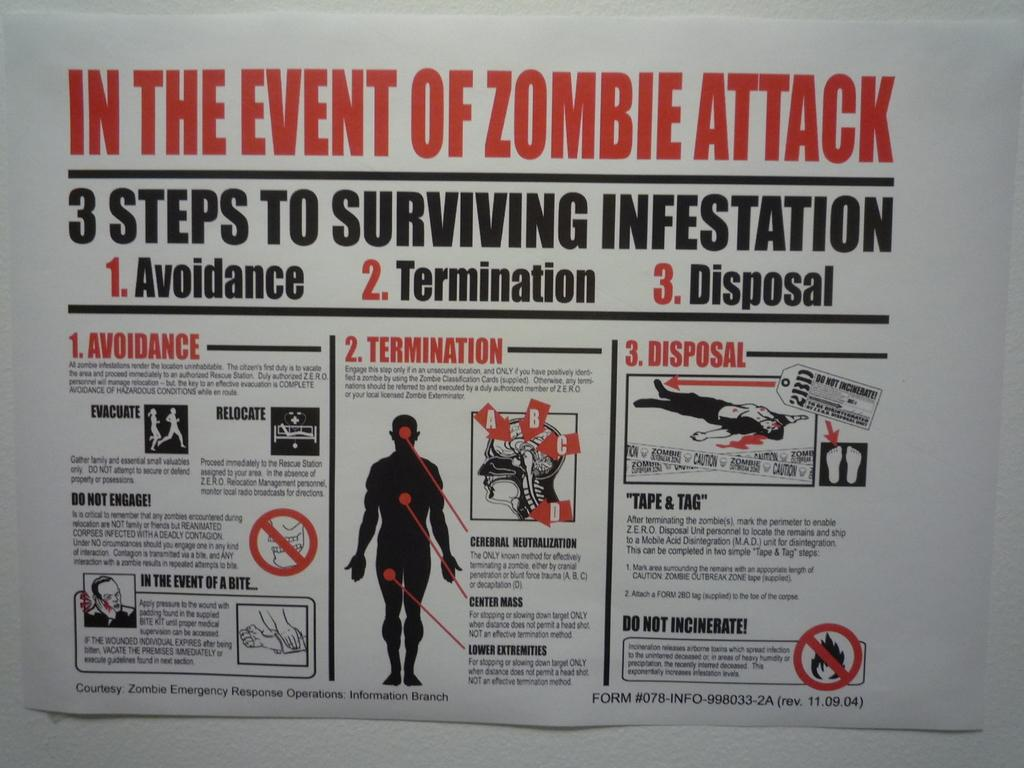<image>
Share a concise interpretation of the image provided. Guide showing what to do in case of a Zombie Attack. 